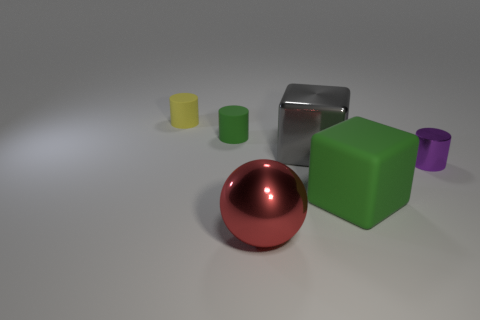How does the lighting in the image affect the appearance of the objects? The lighting in the image casts soft shadows and highlights, giving a three-dimensional quality to the objects. Reflective surfaces, such as the red sphere and the large metallic cube, have bright highlights and distinct reflections that indicate a light source above. The non-metallic objects, like the green cube and the cylinders, have diffused shadows that help delineate their shapes and add depth to the scene. 